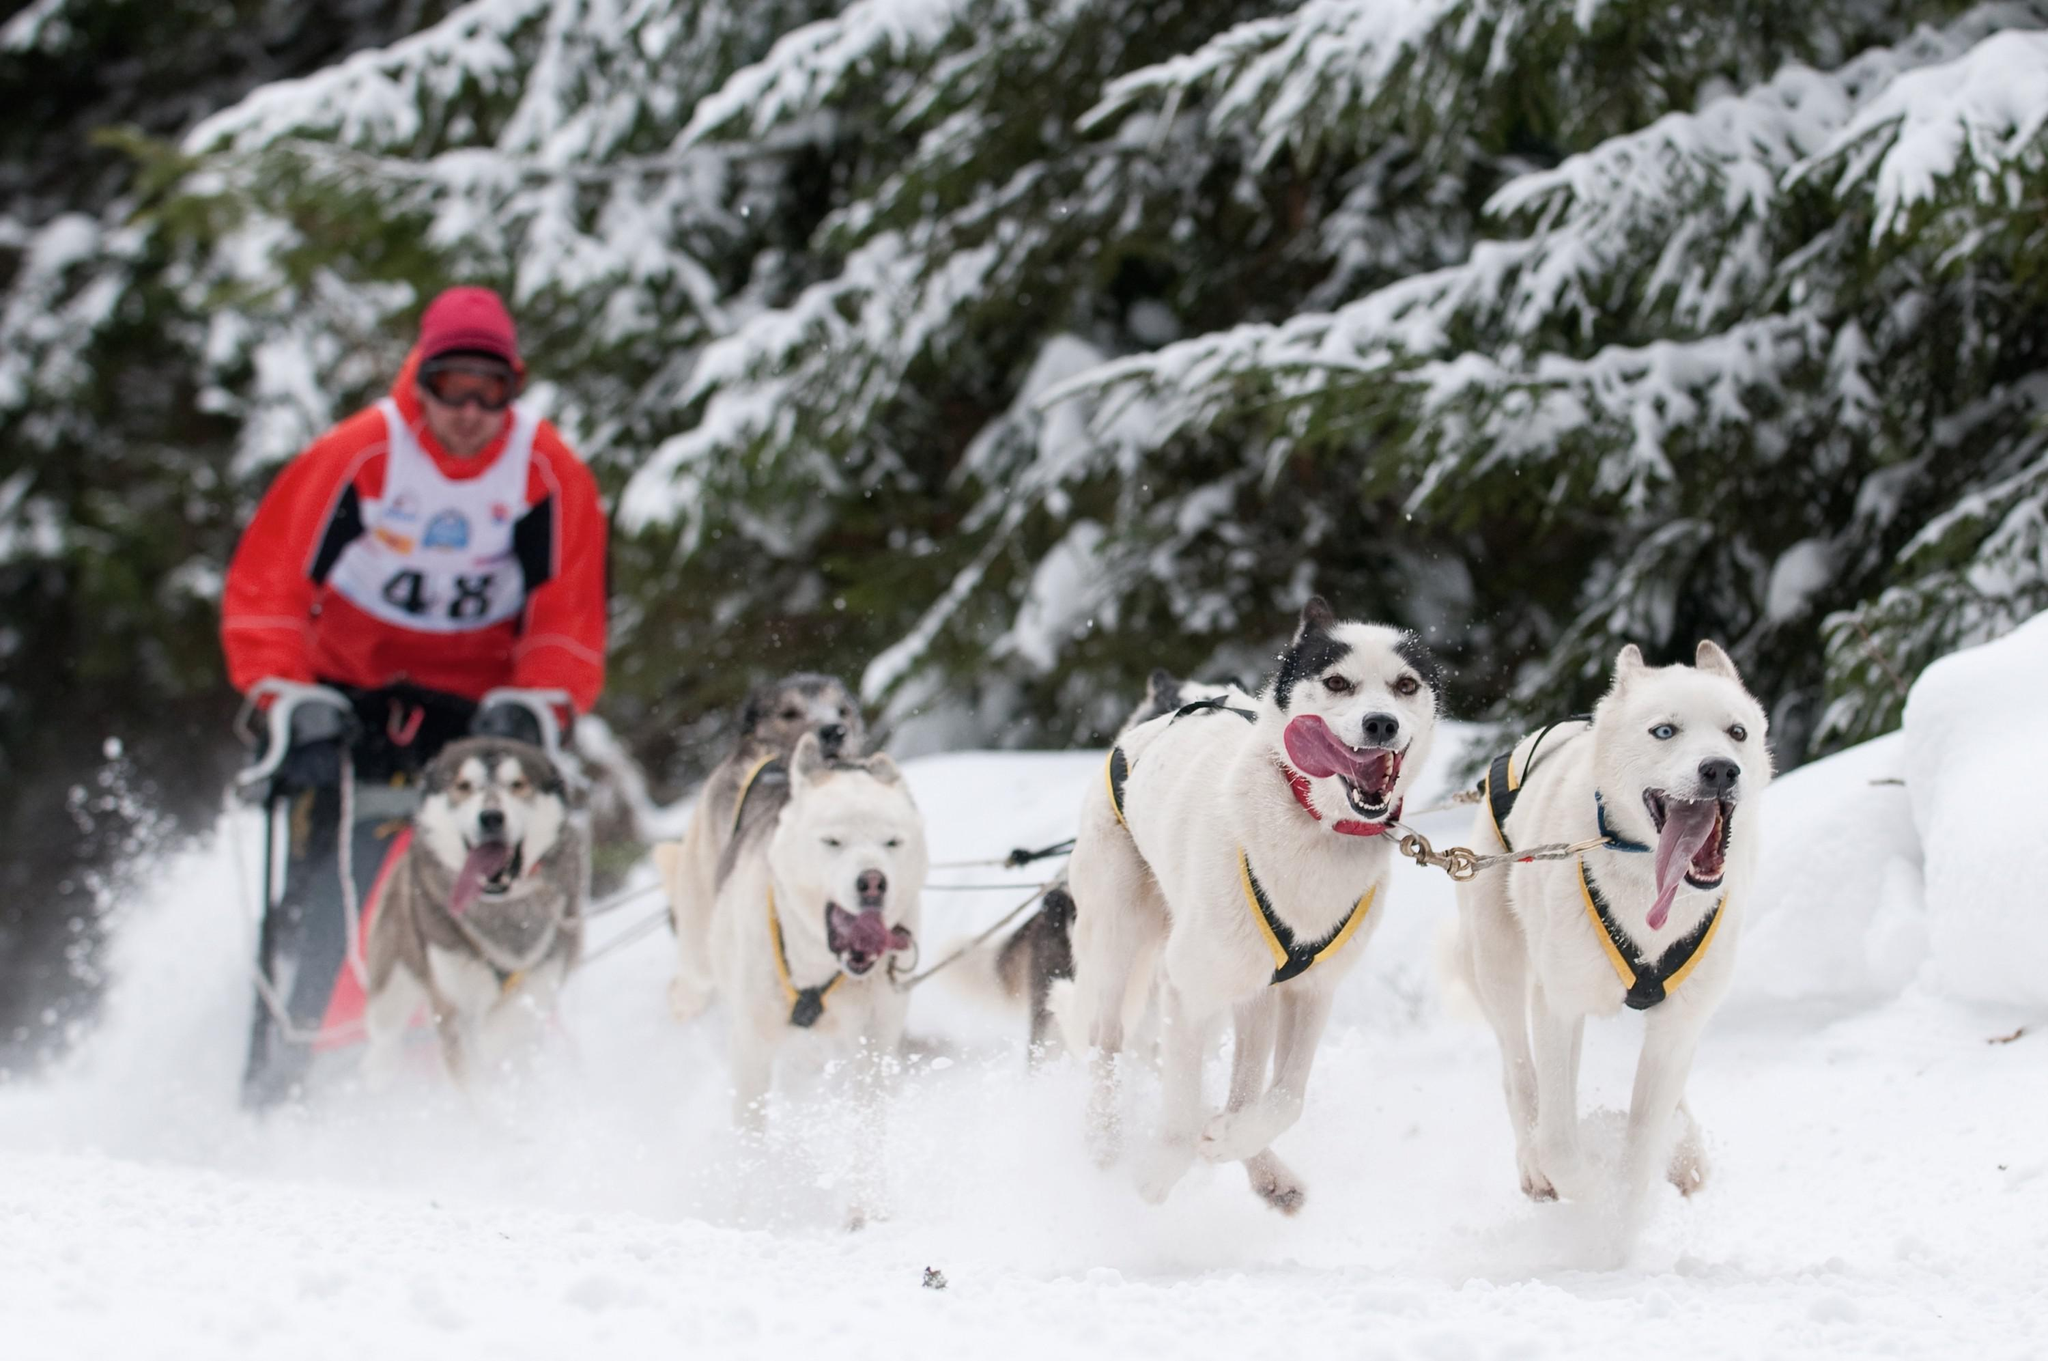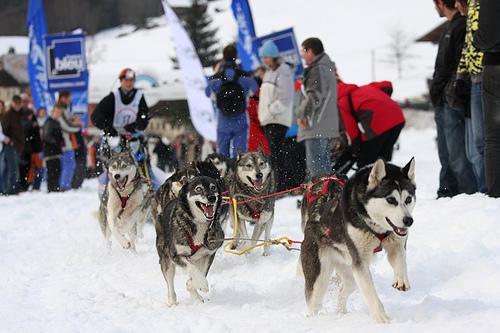The first image is the image on the left, the second image is the image on the right. For the images shown, is this caption "At least one of the drivers is wearing yellow." true? Answer yes or no. No. The first image is the image on the left, the second image is the image on the right. Examine the images to the left and right. Is the description "Two or fewer humans are visible." accurate? Answer yes or no. No. 